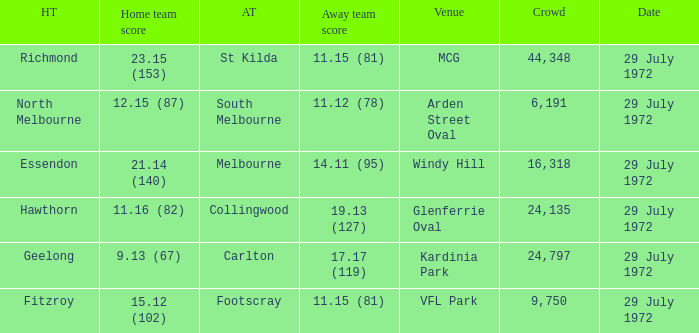I'm looking to parse the entire table for insights. Could you assist me with that? {'header': ['HT', 'Home team score', 'AT', 'Away team score', 'Venue', 'Crowd', 'Date'], 'rows': [['Richmond', '23.15 (153)', 'St Kilda', '11.15 (81)', 'MCG', '44,348', '29 July 1972'], ['North Melbourne', '12.15 (87)', 'South Melbourne', '11.12 (78)', 'Arden Street Oval', '6,191', '29 July 1972'], ['Essendon', '21.14 (140)', 'Melbourne', '14.11 (95)', 'Windy Hill', '16,318', '29 July 1972'], ['Hawthorn', '11.16 (82)', 'Collingwood', '19.13 (127)', 'Glenferrie Oval', '24,135', '29 July 1972'], ['Geelong', '9.13 (67)', 'Carlton', '17.17 (119)', 'Kardinia Park', '24,797', '29 July 1972'], ['Fitzroy', '15.12 (102)', 'Footscray', '11.15 (81)', 'VFL Park', '9,750', '29 July 1972']]} When collingwood was the away team, what was the home team? Hawthorn. 